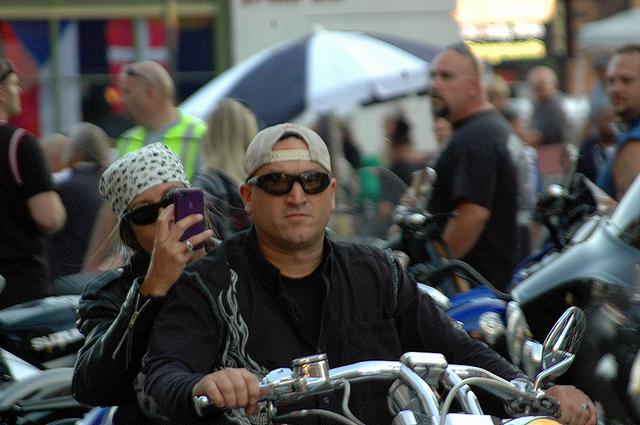Why is the woman wearing a white bandana holding a phone up? taking picture 